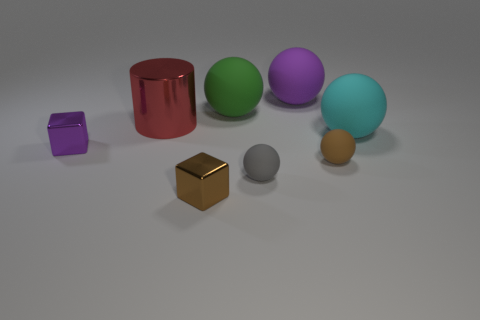What number of other objects are the same material as the cyan object?
Your answer should be compact. 4. Does the large shiny object have the same color as the tiny metallic thing in front of the small purple block?
Offer a very short reply. No. Is the number of gray matte spheres behind the small purple shiny thing greater than the number of large red matte balls?
Offer a very short reply. No. There is a tiny shiny object behind the brown thing that is left of the brown matte sphere; what number of purple spheres are on the right side of it?
Your answer should be very brief. 1. Do the brown object left of the brown matte sphere and the red thing have the same shape?
Keep it short and to the point. No. What is the material of the tiny ball that is left of the tiny brown rubber object?
Ensure brevity in your answer.  Rubber. There is a metallic object that is both in front of the red shiny cylinder and to the left of the brown block; what shape is it?
Keep it short and to the point. Cube. What material is the small gray ball?
Offer a terse response. Rubber. What number of spheres are either purple things or small brown matte things?
Give a very brief answer. 2. Does the tiny brown block have the same material as the cylinder?
Keep it short and to the point. Yes. 